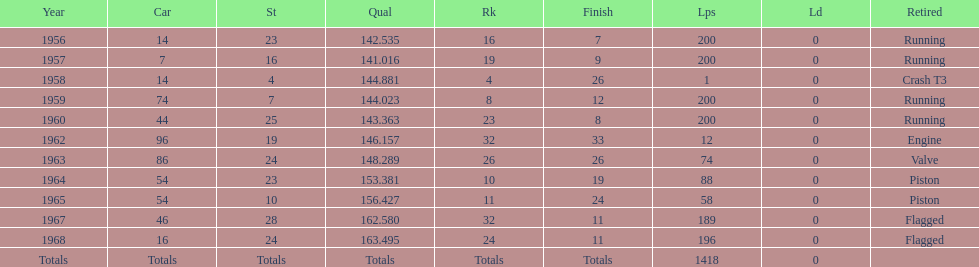In the indy 500, how many instances were there of bob veith being ranked in the top 10? 2. 